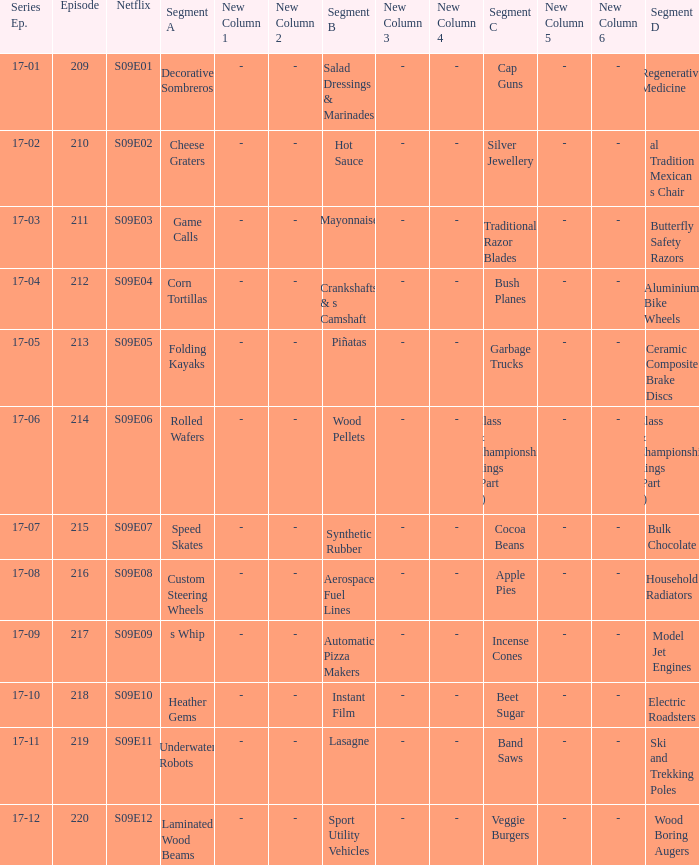Are rolled wafers in many episodes 17-06. 